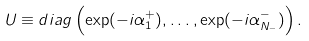Convert formula to latex. <formula><loc_0><loc_0><loc_500><loc_500>U \equiv d i a g \left ( \exp ( - i \alpha _ { 1 } ^ { + } ) , \dots , \exp ( - i \alpha _ { N _ { - } } ^ { - } ) \right ) .</formula> 